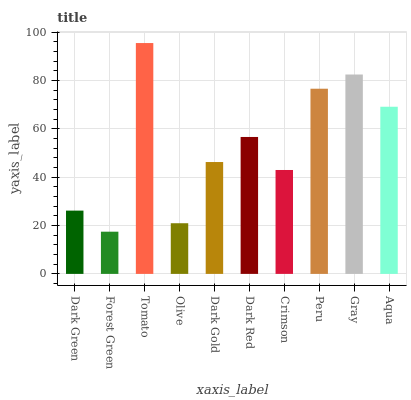Is Forest Green the minimum?
Answer yes or no. Yes. Is Tomato the maximum?
Answer yes or no. Yes. Is Tomato the minimum?
Answer yes or no. No. Is Forest Green the maximum?
Answer yes or no. No. Is Tomato greater than Forest Green?
Answer yes or no. Yes. Is Forest Green less than Tomato?
Answer yes or no. Yes. Is Forest Green greater than Tomato?
Answer yes or no. No. Is Tomato less than Forest Green?
Answer yes or no. No. Is Dark Red the high median?
Answer yes or no. Yes. Is Dark Gold the low median?
Answer yes or no. Yes. Is Dark Gold the high median?
Answer yes or no. No. Is Crimson the low median?
Answer yes or no. No. 